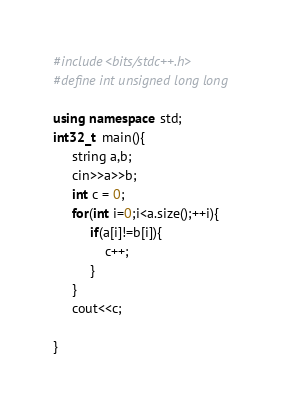<code> <loc_0><loc_0><loc_500><loc_500><_C++_>#include<bits/stdc++.h>
#define int unsigned long long 

using namespace std;
int32_t  main(){
     string a,b;
     cin>>a>>b;
     int c = 0;
     for(int i=0;i<a.size();++i){
          if(a[i]!=b[i]){
              c++;
          }
     }
     cout<<c;
    
}</code> 